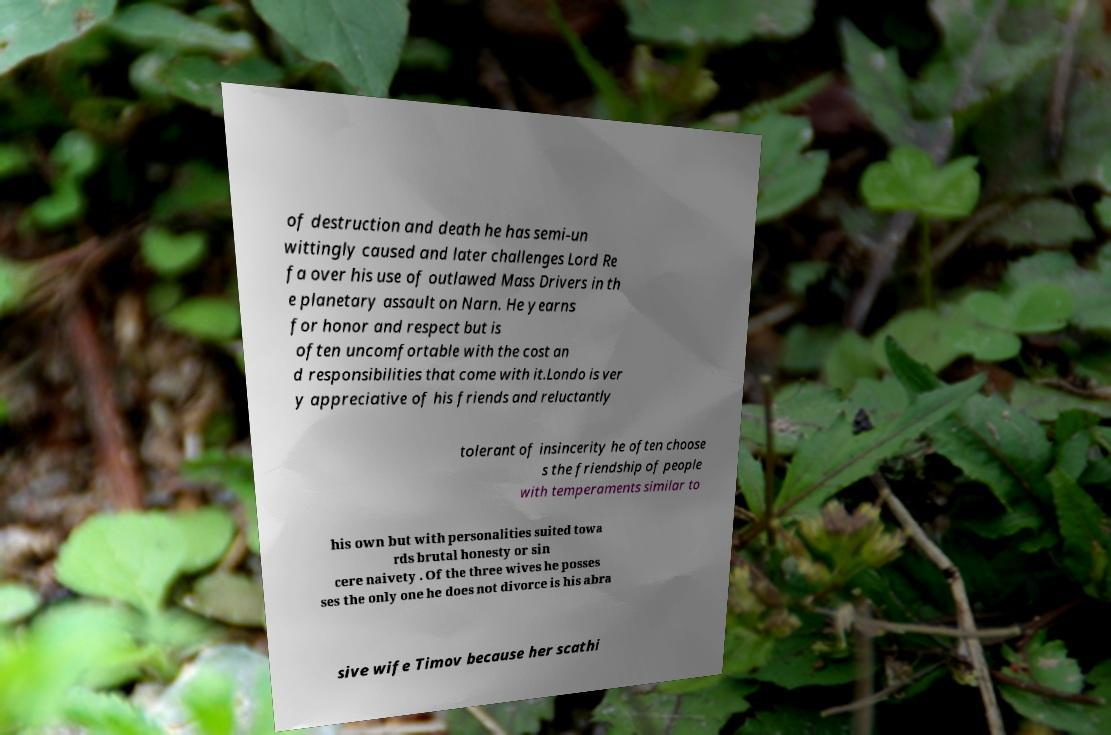Please identify and transcribe the text found in this image. of destruction and death he has semi-un wittingly caused and later challenges Lord Re fa over his use of outlawed Mass Drivers in th e planetary assault on Narn. He yearns for honor and respect but is often uncomfortable with the cost an d responsibilities that come with it.Londo is ver y appreciative of his friends and reluctantly tolerant of insincerity he often choose s the friendship of people with temperaments similar to his own but with personalities suited towa rds brutal honesty or sin cere naivety . Of the three wives he posses ses the only one he does not divorce is his abra sive wife Timov because her scathi 